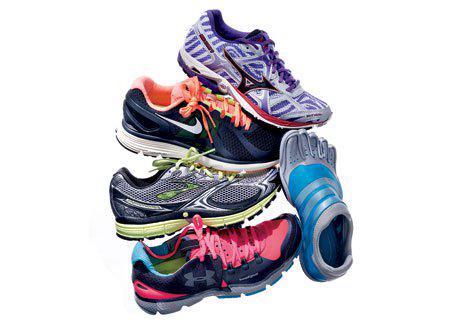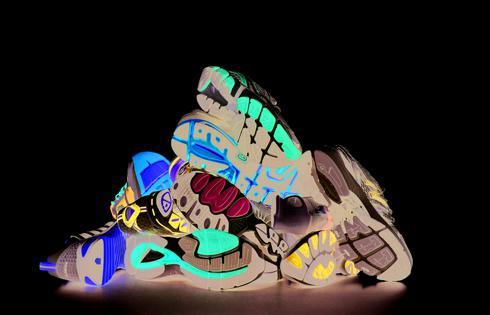The first image is the image on the left, the second image is the image on the right. Evaluate the accuracy of this statement regarding the images: "An image shows no more than a dozen sneakers arranged in a pile with at least one sole visible.". Is it true? Answer yes or no. Yes. The first image is the image on the left, the second image is the image on the right. Examine the images to the left and right. Is the description "The shoes in one of the pictures are not piled up on each other." accurate? Answer yes or no. No. 